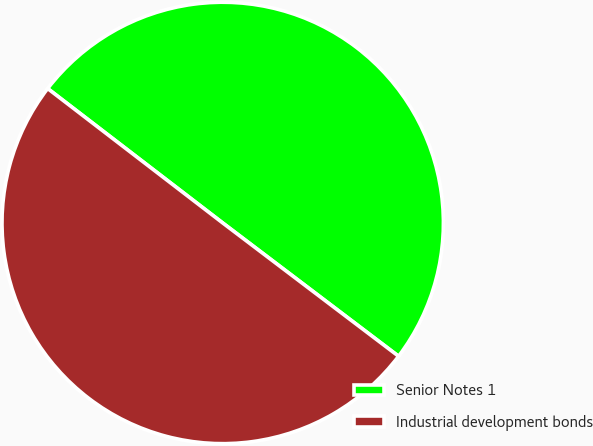Convert chart to OTSL. <chart><loc_0><loc_0><loc_500><loc_500><pie_chart><fcel>Senior Notes 1<fcel>Industrial development bonds<nl><fcel>49.9%<fcel>50.1%<nl></chart> 